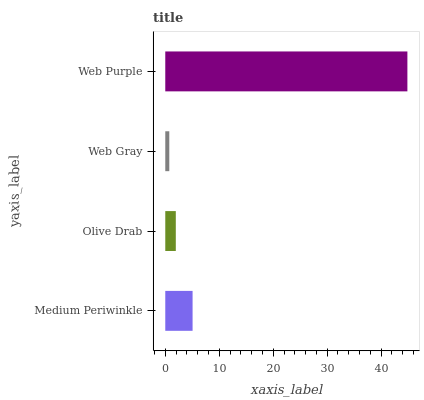Is Web Gray the minimum?
Answer yes or no. Yes. Is Web Purple the maximum?
Answer yes or no. Yes. Is Olive Drab the minimum?
Answer yes or no. No. Is Olive Drab the maximum?
Answer yes or no. No. Is Medium Periwinkle greater than Olive Drab?
Answer yes or no. Yes. Is Olive Drab less than Medium Periwinkle?
Answer yes or no. Yes. Is Olive Drab greater than Medium Periwinkle?
Answer yes or no. No. Is Medium Periwinkle less than Olive Drab?
Answer yes or no. No. Is Medium Periwinkle the high median?
Answer yes or no. Yes. Is Olive Drab the low median?
Answer yes or no. Yes. Is Olive Drab the high median?
Answer yes or no. No. Is Web Gray the low median?
Answer yes or no. No. 